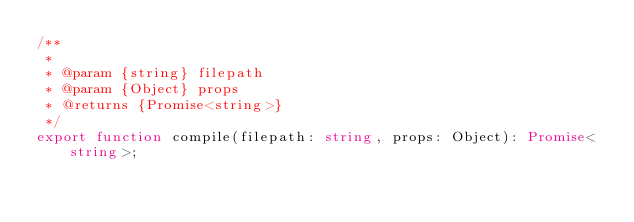<code> <loc_0><loc_0><loc_500><loc_500><_TypeScript_>/**
 *
 * @param {string} filepath
 * @param {Object} props
 * @returns {Promise<string>}
 */
export function compile(filepath: string, props: Object): Promise<string>;
</code> 